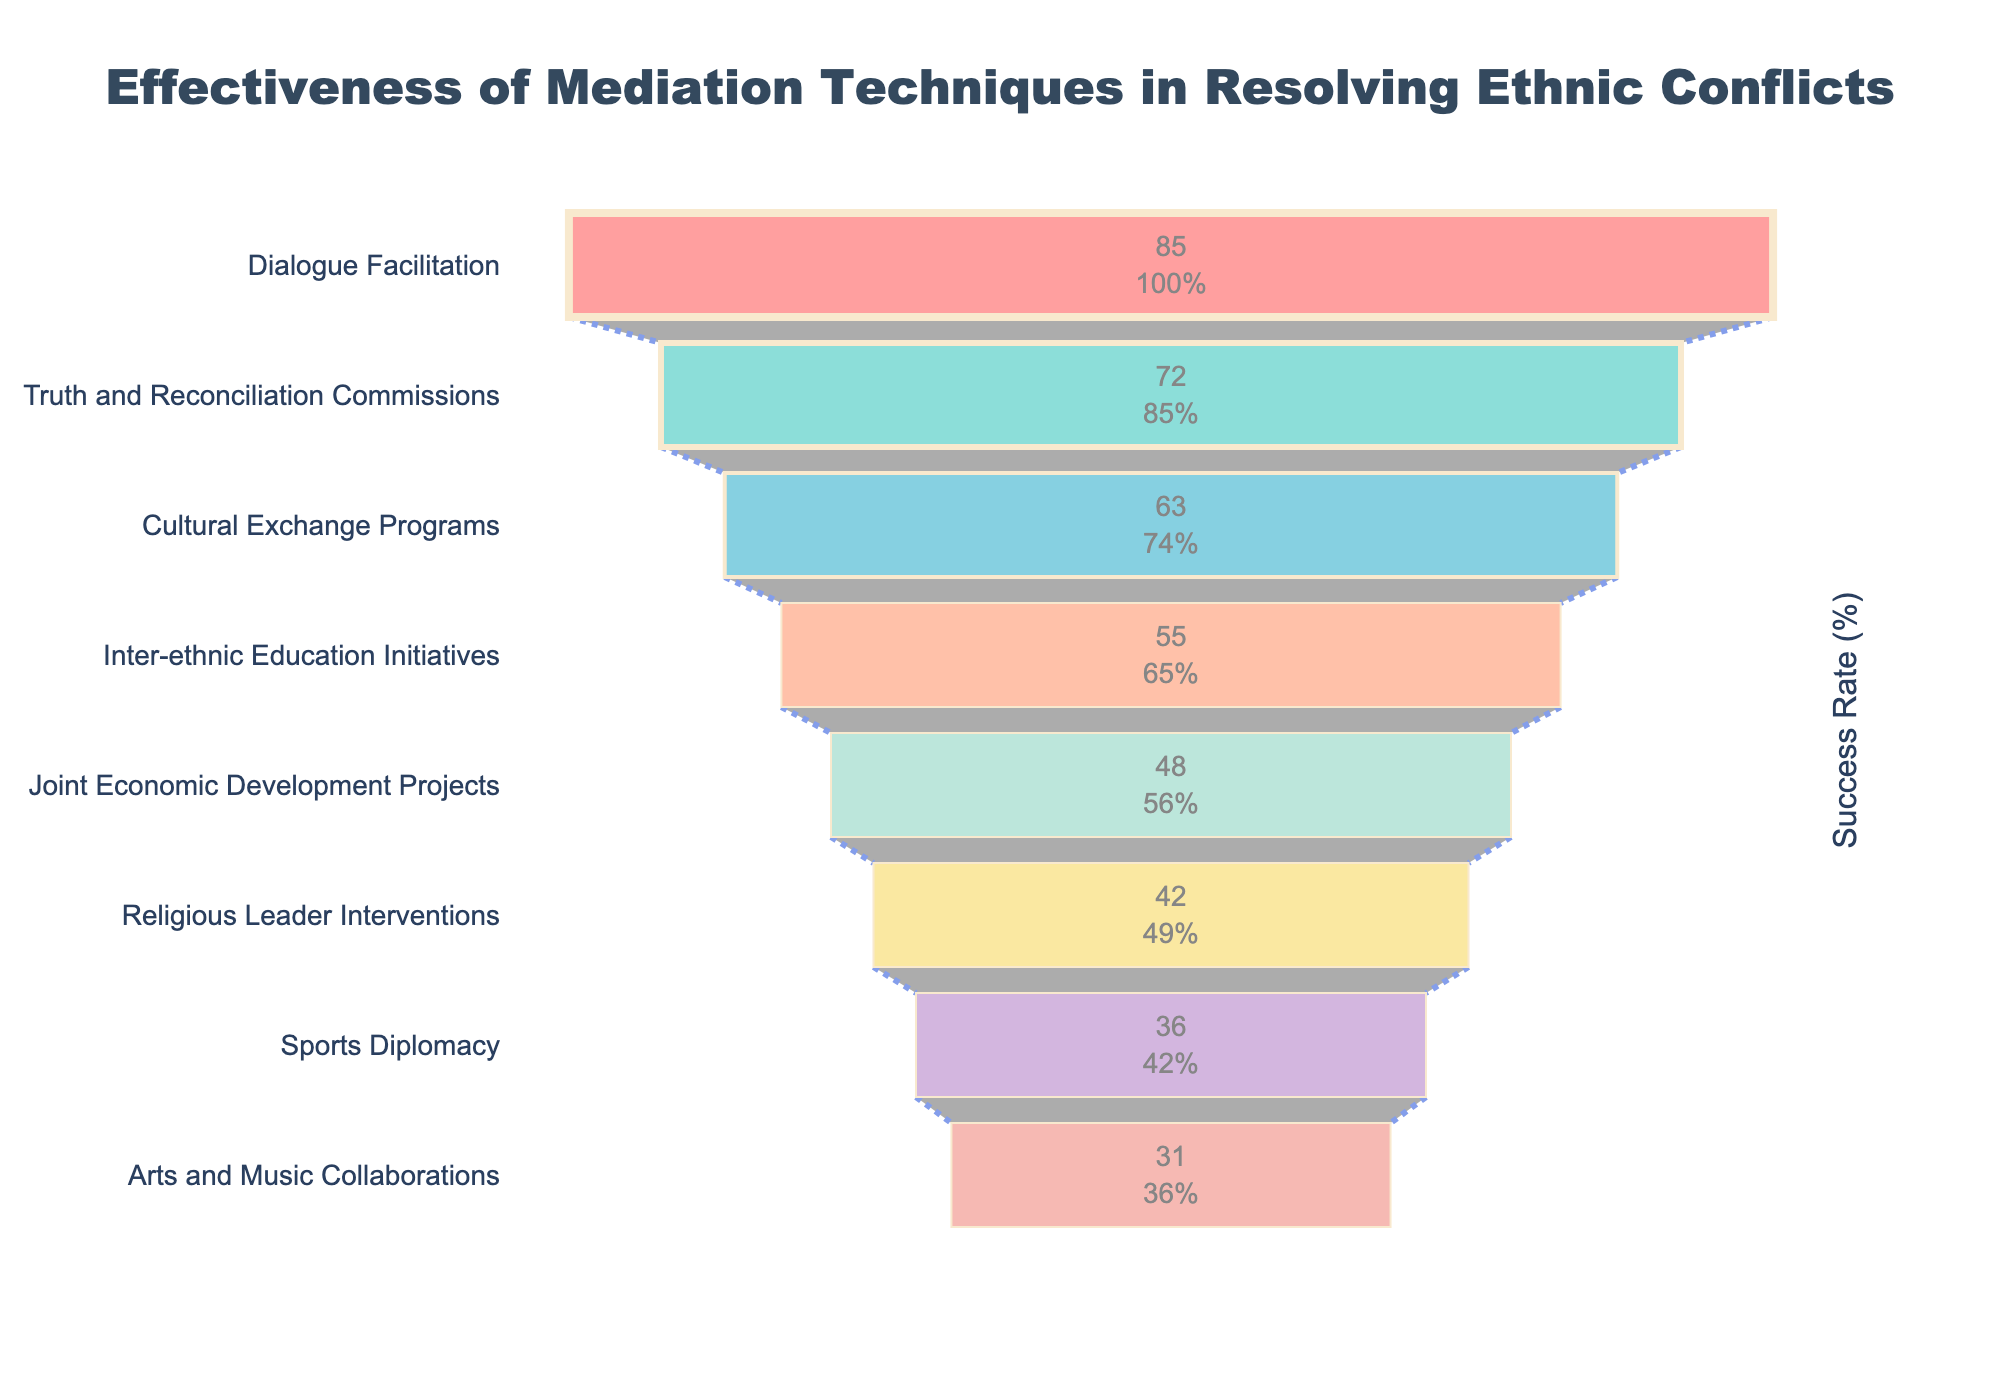What's the title of the figure? The title is located at the top of the figure, providing a summary of the data presented in the chart. It reads: "Effectiveness of Mediation Techniques in Resolving Ethnic Conflicts".
Answer: Effectiveness of Mediation Techniques in Resolving Ethnic Conflicts Which mediation technique has the highest success rate? The mediation technique at the top of the funnel chart represents the one with the highest success rate. According to the data, the technique listed is "Dialogue Facilitation" with 85%.
Answer: Dialogue Facilitation How many mediation techniques have a success rate above 50%? Count the number of techniques whose bars extend beyond the midpoint of the x-axis. Techniques above 50% are "Dialogue Facilitation", "Truth and Reconciliation Commissions", "Cultural Exchange Programs", and "Inter-ethnic Education Initiatives". Thus, there are four techniques.
Answer: 4 Which mediation technique appears to be the least successful? The least successful technique will be at the bottom of the funnel chart. Based on the data, "Arts and Music Collaborations" is the last technique listed, with a success rate of 31%.
Answer: Arts and Music Collaborations What is the success rate difference between the most and least successful mediation techniques? Subtract the success rate of the least successful technique from the most successful one. "Dialogue Facilitation" has an 85% success rate, and "Arts and Music Collaborations" has a 31% success rate. So, the difference is 85% - 31% = 54%.
Answer: 54% Are there any mediation techniques with a success rate between 40% and 50%? Identify the techniques whose success rates fall between 40% and 50%. According to the data, "Joint Economic Development Projects" (48%) and "Religious Leader Interventions" (42%) fall in this range.
Answer: Yes Which mediation technique is positioned midway in terms of its success rate? The technique in the middle of the funnel chart represents the median success rate visually. For eight techniques, the fourth and fifth are "Inter-ethnic Education Initiatives" and "Joint Economic Development Projects". Analyzing the data shows "Inter-ethnic Education Initiatives" (55%) is positioned before "Joint Economic Development Projects" (48%), so "Inter-ethnic Education Initiatives" is the median.
Answer: Inter-ethnic Education Initiatives What is the approximate success rate percentage difference between cultural exchange programs and sports diplomacy techniques? Subtract the success rate of "Sports Diplomacy" (36%) from "Cultural Exchange Programs" (63%). The percentage difference is 63% - 36% = 27%.
Answer: 27% Among the mediation techniques with success rates below 50%, which one is closest to a 50% success rate? Identify the technique below 50% and closest to it. "Joint Economic Development Projects" has a success rate of 48%, which is the closest to 50% among those below this threshold.
Answer: Joint Economic Development Projects What percentage of the initial value does truth and reconciliation commissions represents? From the text information inside the chart, refer to the right of the bar for "Truth and Reconciliation Commissions" to find its percentage of the initial value.
Answer: The specific percentage is not given on this dataset, but the initial value is considered as "Dialogue Facilitation" (85%) and "Truth and Reconciliation Commissions" are 72/85 = 84.7% approximately 